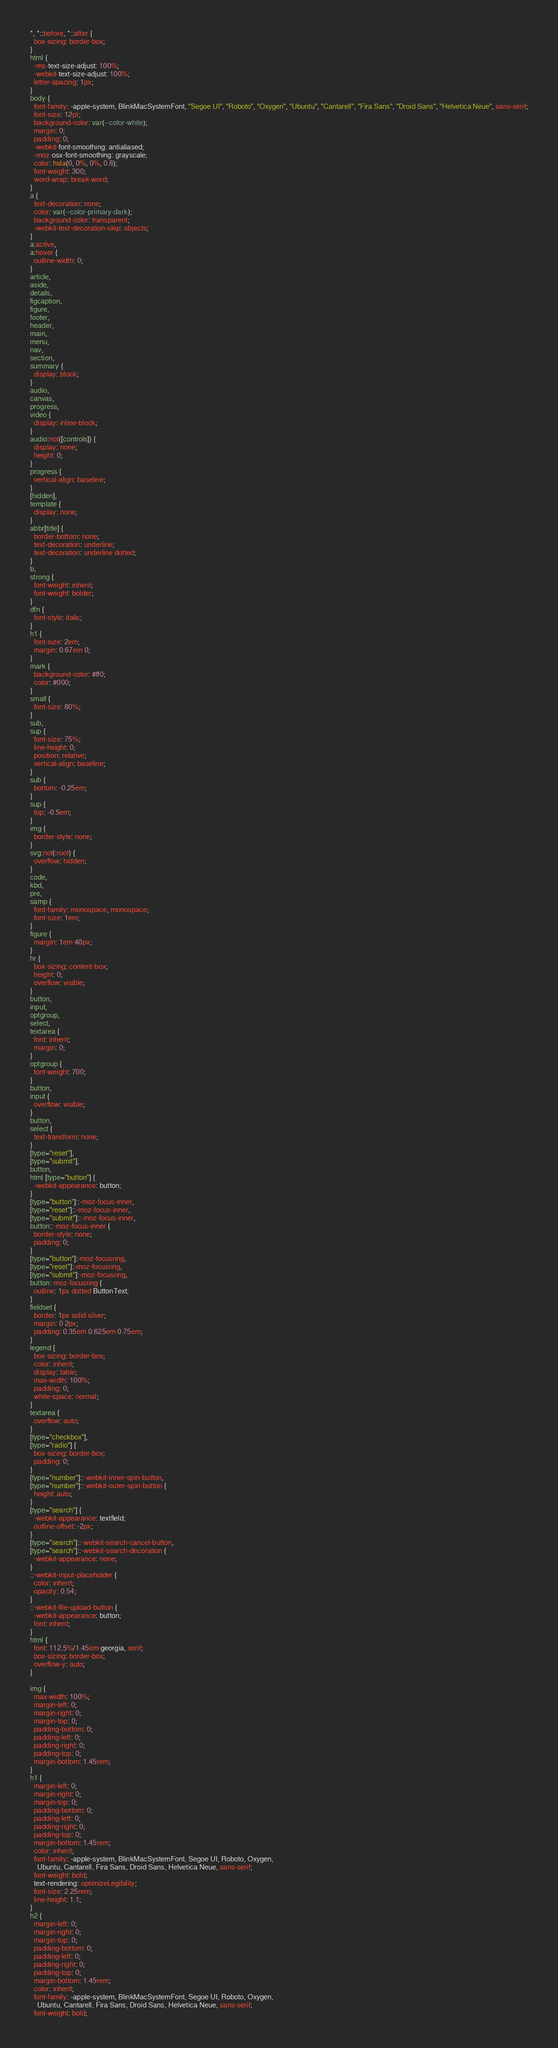Convert code to text. <code><loc_0><loc_0><loc_500><loc_500><_CSS_>*, *::before, *::after {
  box-sizing: border-box;
}
html {
  -ms-text-size-adjust: 100%;
  -webkit-text-size-adjust: 100%;
  letter-spacing: 1px;
}
body {
  font-family: -apple-system, BlinkMacSystemFont, "Segoe UI", "Roboto", "Oxygen", "Ubuntu", "Cantarell", "Fira Sans", "Droid Sans", "Helvetica Neue", sans-serif;
  font-size: 12pt;
  background-color: var(--color-white);
  margin: 0;
  padding: 0;
  -webkit-font-smoothing: antialiased;
  -moz-osx-font-smoothing: grayscale;
  color: hsla(0, 0%, 0%, 0.8);
  font-weight: 300;
  word-wrap: break-word;
}
a {
  text-decoration: none;
  color: var(--color-primary-dark);
  background-color: transparent;
  -webkit-text-decoration-skip: objects;
}
a:active,
a:hover {
  outline-width: 0;
}
article,
aside,
details,
figcaption,
figure,
footer,
header,
main,
menu,
nav,
section,
summary {
  display: block;
}
audio,
canvas,
progress,
video {
  display: inline-block;
}
audio:not([controls]) {
  display: none;
  height: 0;
}
progress {
  vertical-align: baseline;
}
[hidden],
template {
  display: none;
}
abbr[title] {
  border-bottom: none;
  text-decoration: underline;
  text-decoration: underline dotted;
}
b,
strong {
  font-weight: inherit;
  font-weight: bolder;
}
dfn {
  font-style: italic;
}
h1 {
  font-size: 2em;
  margin: 0.67em 0;
}
mark {
  background-color: #ff0;
  color: #000;
}
small {
  font-size: 80%;
}
sub,
sup {
  font-size: 75%;
  line-height: 0;
  position: relative;
  vertical-align: baseline;
}
sub {
  bottom: -0.25em;
}
sup {
  top: -0.5em;
}
img {
  border-style: none;
}
svg:not(:root) {
  overflow: hidden;
}
code,
kbd,
pre,
samp {
  font-family: monospace, monospace;
  font-size: 1em;
}
figure {
  margin: 1em 40px;
}
hr {
  box-sizing: content-box;
  height: 0;
  overflow: visible;
}
button,
input,
optgroup,
select,
textarea {
  font: inherit;
  margin: 0;
}
optgroup {
  font-weight: 700;
}
button,
input {
  overflow: visible;
}
button,
select {
  text-transform: none;
}
[type="reset"],
[type="submit"],
button,
html [type="button"] {
  -webkit-appearance: button;
}
[type="button"]::-moz-focus-inner,
[type="reset"]::-moz-focus-inner,
[type="submit"]::-moz-focus-inner,
button::-moz-focus-inner {
  border-style: none;
  padding: 0;
}
[type="button"]:-moz-focusring,
[type="reset"]:-moz-focusring,
[type="submit"]:-moz-focusring,
button:-moz-focusring {
  outline: 1px dotted ButtonText;
}
fieldset {
  border: 1px solid silver;
  margin: 0 2px;
  padding: 0.35em 0.625em 0.75em;
}
legend {
  box-sizing: border-box;
  color: inherit;
  display: table;
  max-width: 100%;
  padding: 0;
  white-space: normal;
}
textarea {
  overflow: auto;
}
[type="checkbox"],
[type="radio"] {
  box-sizing: border-box;
  padding: 0;
}
[type="number"]::-webkit-inner-spin-button,
[type="number"]::-webkit-outer-spin-button {
  height: auto;
}
[type="search"] {
  -webkit-appearance: textfield;
  outline-offset: -2px;
}
[type="search"]::-webkit-search-cancel-button,
[type="search"]::-webkit-search-decoration {
  -webkit-appearance: none;
}
::-webkit-input-placeholder {
  color: inherit;
  opacity: 0.54;
}
::-webkit-file-upload-button {
  -webkit-appearance: button;
  font: inherit;
}
html {
  font: 112.5%/1.45em georgia, serif;
  box-sizing: border-box;
  overflow-y: auto;
}

img {
  max-width: 100%;
  margin-left: 0;
  margin-right: 0;
  margin-top: 0;
  padding-bottom: 0;
  padding-left: 0;
  padding-right: 0;
  padding-top: 0;
  margin-bottom: 1.45rem;
}
h1 {
  margin-left: 0;
  margin-right: 0;
  margin-top: 0;
  padding-bottom: 0;
  padding-left: 0;
  padding-right: 0;
  padding-top: 0;
  margin-bottom: 1.45rem;
  color: inherit;
  font-family: -apple-system, BlinkMacSystemFont, Segoe UI, Roboto, Oxygen,
    Ubuntu, Cantarell, Fira Sans, Droid Sans, Helvetica Neue, sans-serif;
  font-weight: bold;
  text-rendering: optimizeLegibility;
  font-size: 2.25rem;
  line-height: 1.1;
}
h2 {
  margin-left: 0;
  margin-right: 0;
  margin-top: 0;
  padding-bottom: 0;
  padding-left: 0;
  padding-right: 0;
  padding-top: 0;
  margin-bottom: 1.45rem;
  color: inherit;
  font-family: -apple-system, BlinkMacSystemFont, Segoe UI, Roboto, Oxygen,
    Ubuntu, Cantarell, Fira Sans, Droid Sans, Helvetica Neue, sans-serif;
  font-weight: bold;</code> 